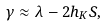<formula> <loc_0><loc_0><loc_500><loc_500>\gamma \approx \lambda - 2 h _ { K } S ,</formula> 